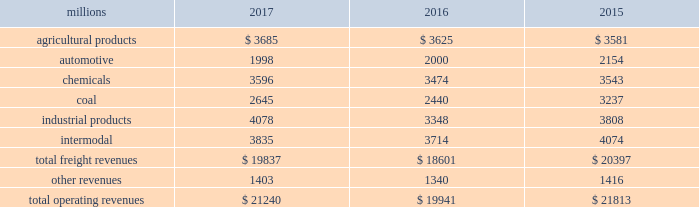Notes to the consolidated financial statements union pacific corporation and subsidiary companies for purposes of this report , unless the context otherwise requires , all references herein to the 201ccorporation 201d , 201ccompany 201d , 201cupc 201d , 201cwe 201d , 201cus 201d , and 201cour 201d mean union pacific corporation and its subsidiaries , including union pacific railroad company , which will be separately referred to herein as 201cuprr 201d or the 201crailroad 201d .
Nature of operations operations and segmentation 2013 we are a class i railroad operating in the u.s .
Our network includes 32122 route miles , linking pacific coast and gulf coast ports with the midwest and eastern u.s .
Gateways and providing several corridors to key mexican gateways .
We own 26042 miles and operate on the remainder pursuant to trackage rights or leases .
We serve the western two-thirds of the country and maintain coordinated schedules with other rail carriers for the handling of freight to and from the atlantic coast , the pacific coast , the southeast , the southwest , canada , and mexico .
Export and import traffic is moved through gulf coast and pacific coast ports and across the mexican and canadian borders .
The railroad , along with its subsidiaries and rail affiliates , is our one reportable operating segment .
Although we provide and analyze revenue by commodity group , we treat the financial results of the railroad as one segment due to the integrated nature of our rail network .
The table provides freight revenue by commodity group: .
Although our revenues are principally derived from customers domiciled in the u.s. , the ultimate points of origination or destination for some products we transport are outside the u.s .
Each of our commodity groups includes revenue from shipments to and from mexico .
Included in the above table are freight revenues from our mexico business which amounted to $ 2.3 billion in 2017 , $ 2.2 billion in 2016 , and $ 2.2 billion in 2015 .
Basis of presentation 2013 the consolidated financial statements are presented in accordance with accounting principles generally accepted in the u.s .
( gaap ) as codified in the financial accounting standards board ( fasb ) accounting standards codification ( asc ) .
Significant accounting policies principles of consolidation 2013 the consolidated financial statements include the accounts of union pacific corporation and all of its subsidiaries .
Investments in affiliated companies ( 20% ( 20 % ) to 50% ( 50 % ) owned ) are accounted for using the equity method of accounting .
All intercompany transactions are eliminated .
We currently have no less than majority-owned investments that require consolidation under variable interest entity requirements .
Cash and cash equivalents 2013 cash equivalents consist of investments with original maturities of three months or less .
Accounts receivable 2013 accounts receivable includes receivables reduced by an allowance for doubtful accounts .
The allowance is based upon historical losses , credit worthiness of customers , and current economic conditions .
Receivables not expected to be collected in one year and the associated allowances are classified as other assets in our consolidated statements of financial position. .
What percentage of total freight revenues was the agricultural commodity group in 2016? 
Computations: (3625 / 18601)
Answer: 0.19488. 